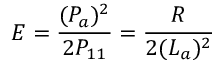Convert formula to latex. <formula><loc_0><loc_0><loc_500><loc_500>E = \frac { ( P _ { a } ) ^ { 2 } } { 2 P _ { 1 1 } } = \frac { R } { 2 ( L _ { a } ) ^ { 2 } }</formula> 